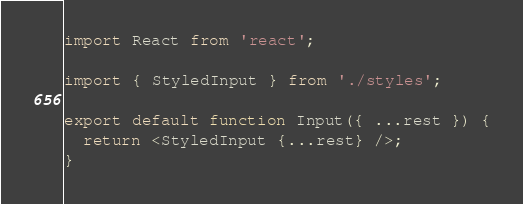<code> <loc_0><loc_0><loc_500><loc_500><_JavaScript_>import React from 'react';

import { StyledInput } from './styles';

export default function Input({ ...rest }) {
  return <StyledInput {...rest} />;
}
</code> 